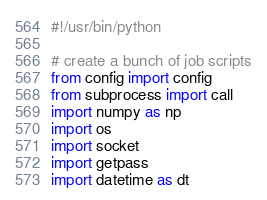Convert code to text. <code><loc_0><loc_0><loc_500><loc_500><_Python_>#!/usr/bin/python

# create a bunch of job scripts
from config import config
from subprocess import call
import numpy as np
import os
import socket
import getpass
import datetime as dt

</code> 